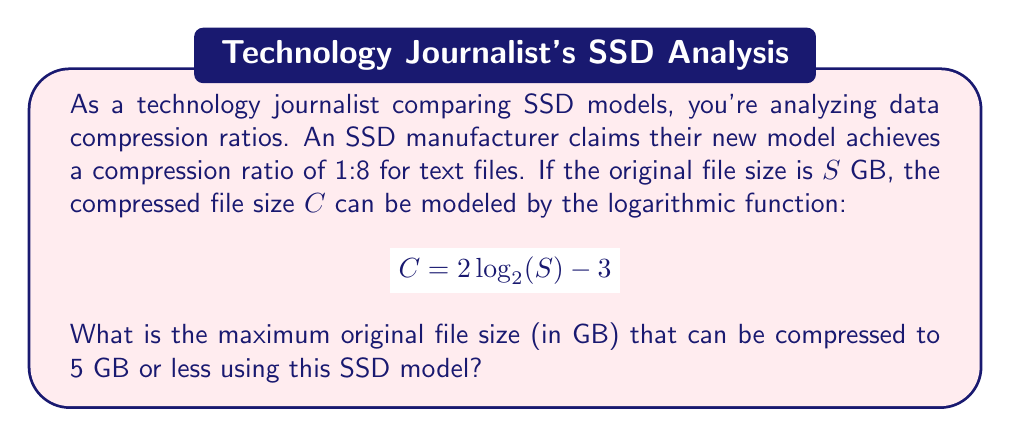Show me your answer to this math problem. To solve this problem, we'll follow these steps:

1) We're given the logarithmic function: $C = 2 \log_2(S) - 3$

2) We want to find the maximum value of $S$ when $C \leq 5$. Let's start by setting $C = 5$:

   $5 = 2 \log_2(S) - 3$

3) Add 3 to both sides:

   $8 = 2 \log_2(S)$

4) Divide both sides by 2:

   $4 = \log_2(S)$

5) To solve for $S$, we need to apply the inverse function (exponential) to both sides:

   $2^4 = 2^{\log_2(S)}$

6) Simplify the left side:

   $16 = S$

Therefore, the maximum original file size that can be compressed to 5 GB or less is 16 GB.

This aligns with the claimed 1:8 compression ratio, as 16 GB compressed to 5 GB is slightly better than 1:8 (it's actually 1:3.2).
Answer: 16 GB 